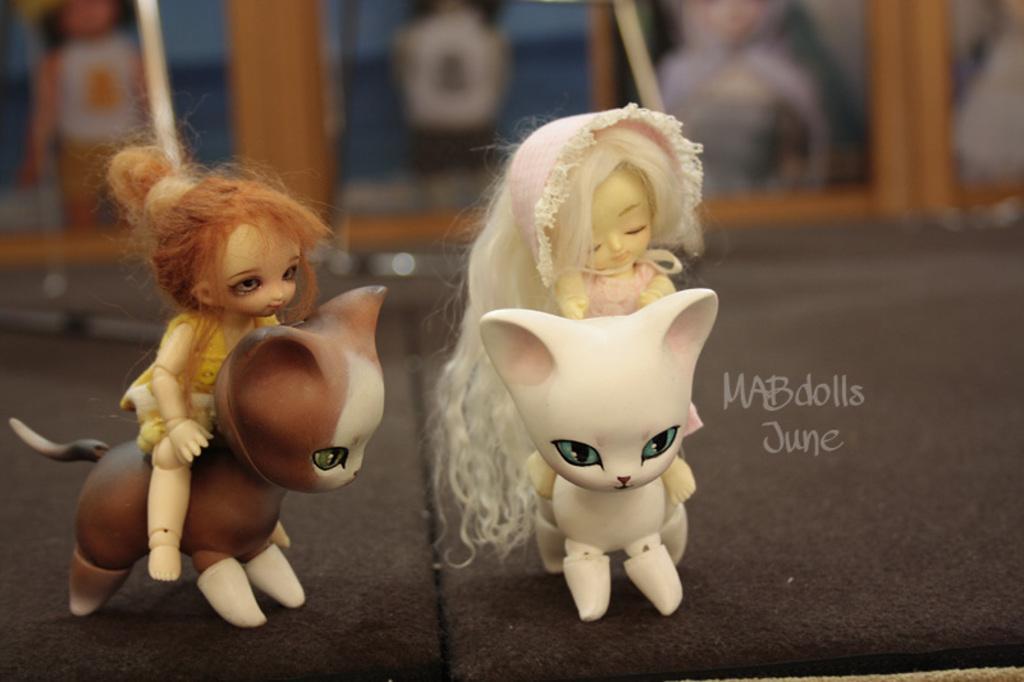Can you describe this image briefly? We can see toys on the surface and we can see text. In the background it is blur. 